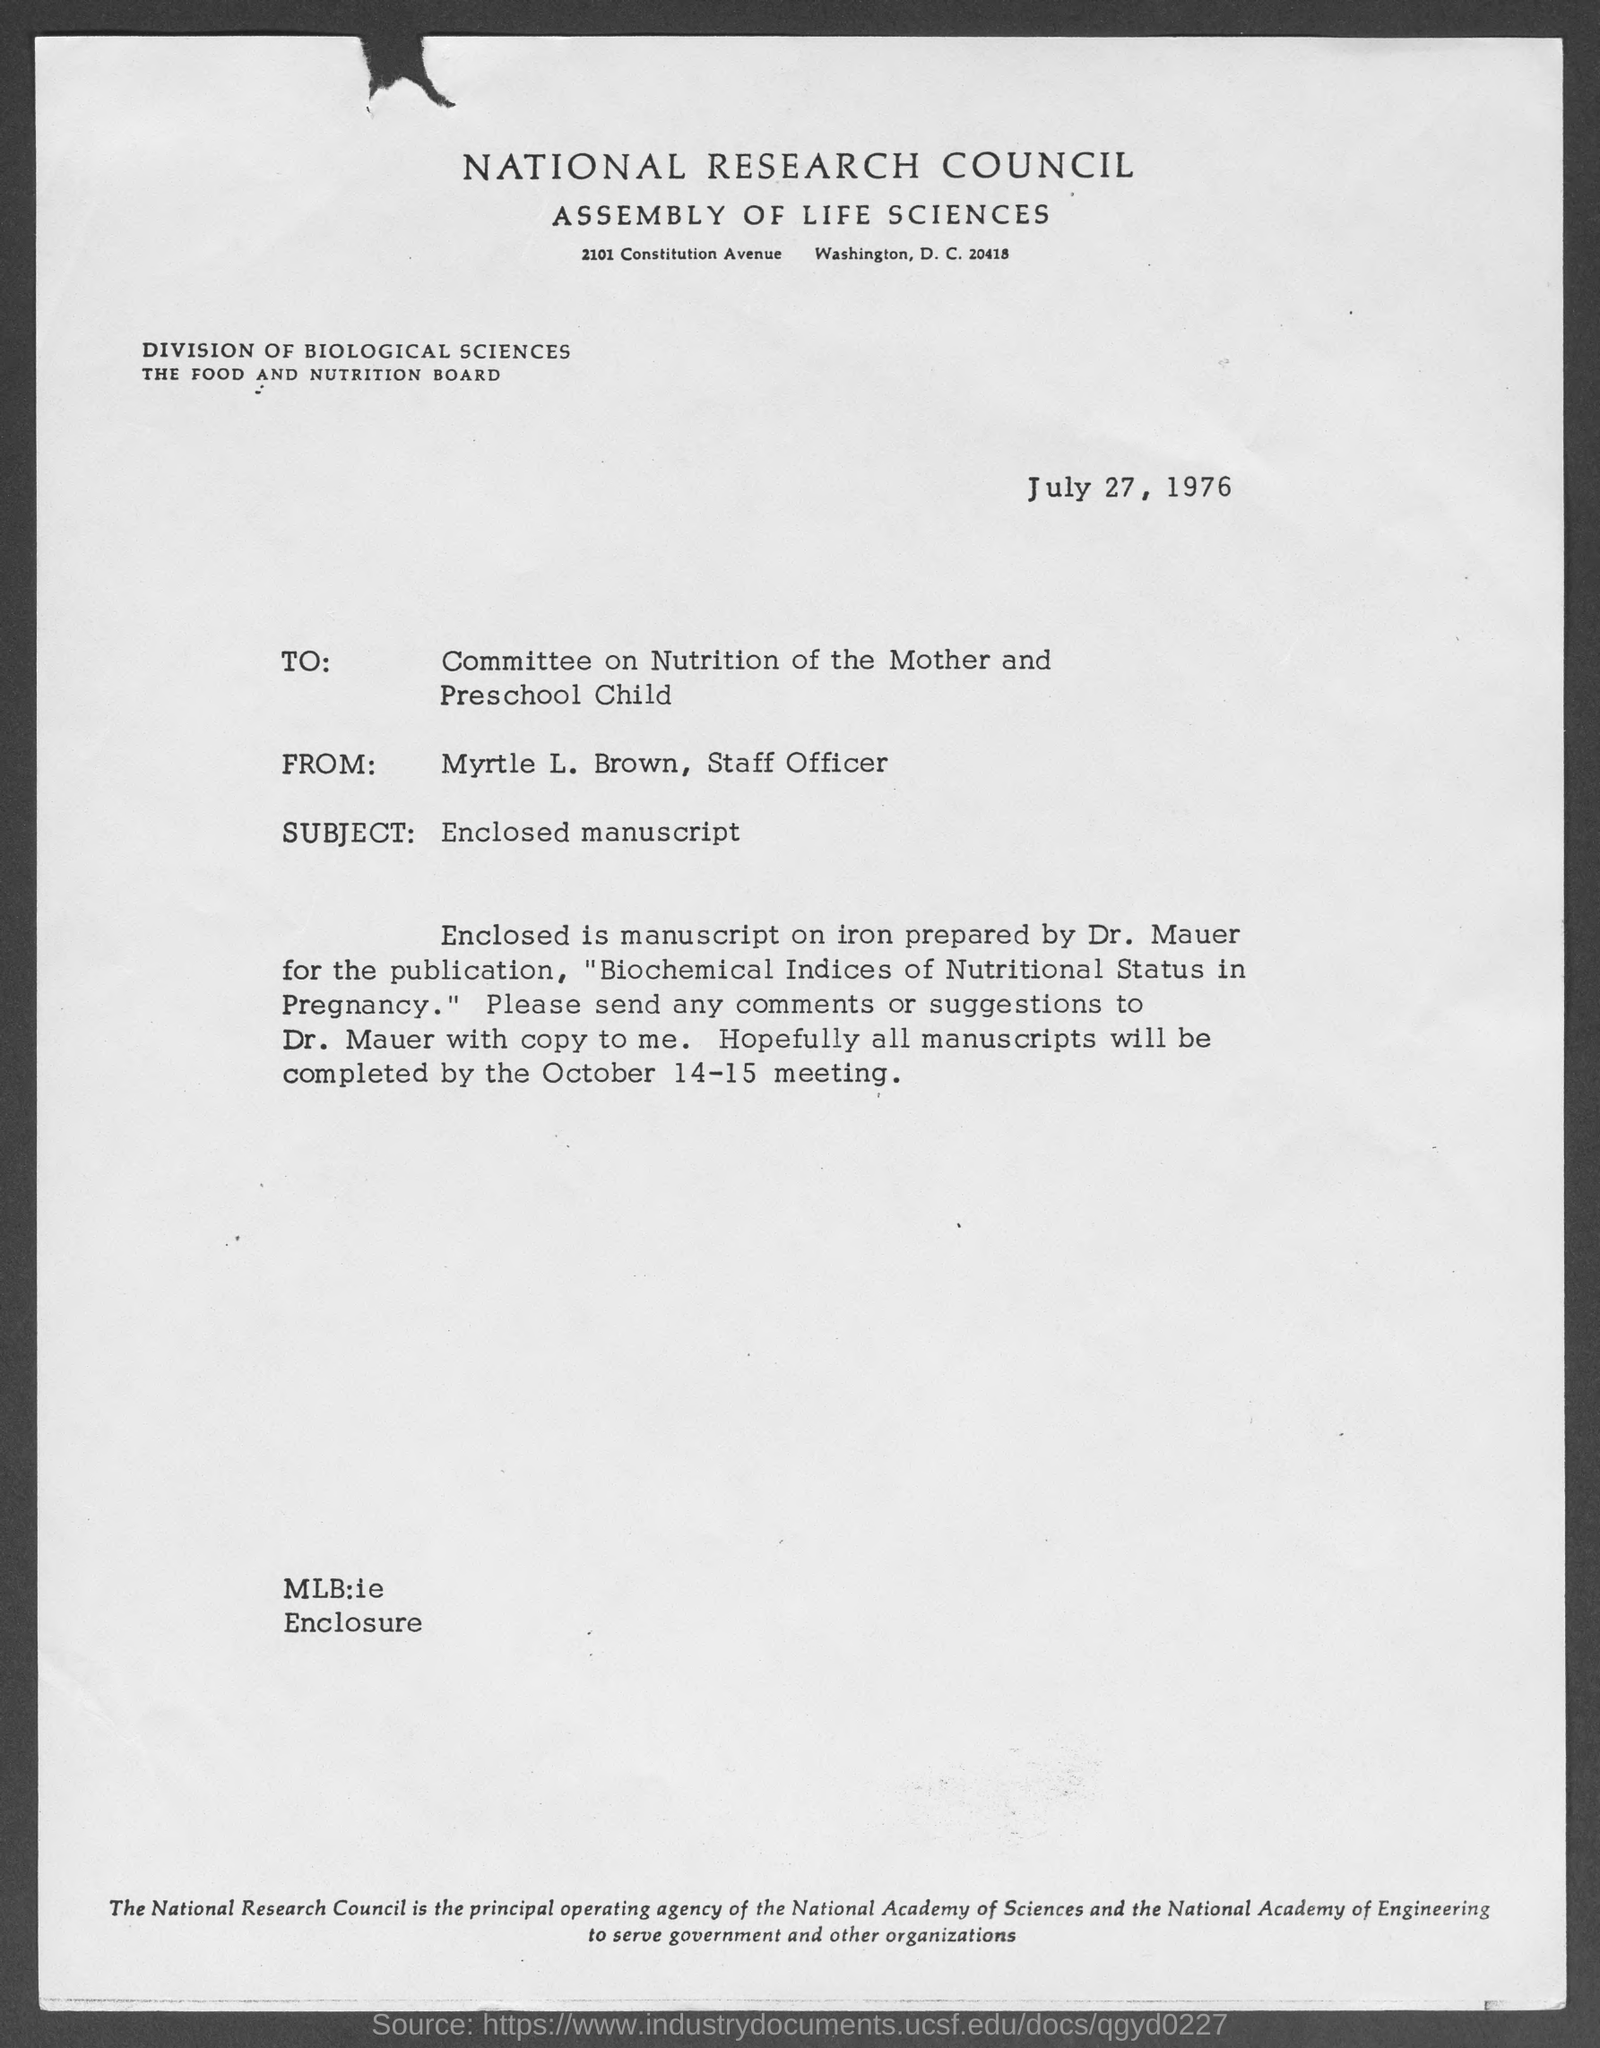what is the street address of National Research Council Assembly of Life Sciences ? The street address of the National Research Council Assembly of Life Sciences is 2101 Constitution Avenue, Washington, D.C. 20418, as indicated in the document dated July 27, 1976. 